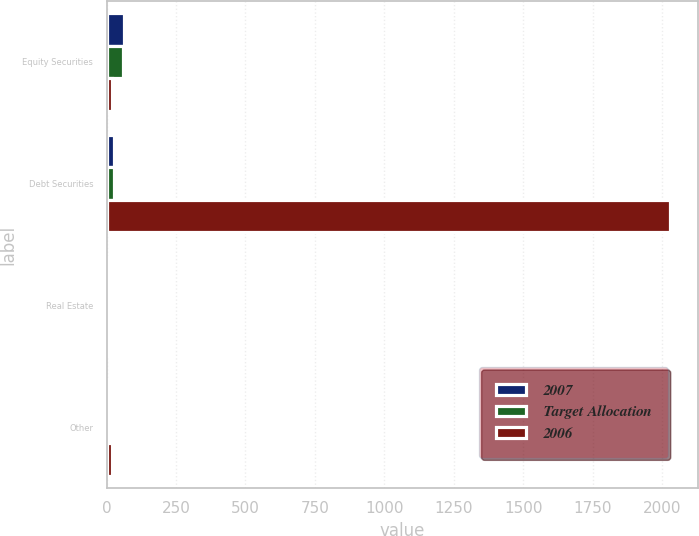Convert chart to OTSL. <chart><loc_0><loc_0><loc_500><loc_500><stacked_bar_chart><ecel><fcel>Equity Securities<fcel>Debt Securities<fcel>Real Estate<fcel>Other<nl><fcel>2007<fcel>62<fcel>28<fcel>5<fcel>5<nl><fcel>Target Allocation<fcel>61<fcel>27<fcel>5<fcel>7<nl><fcel>2006<fcel>20<fcel>2030<fcel>8<fcel>20<nl></chart> 